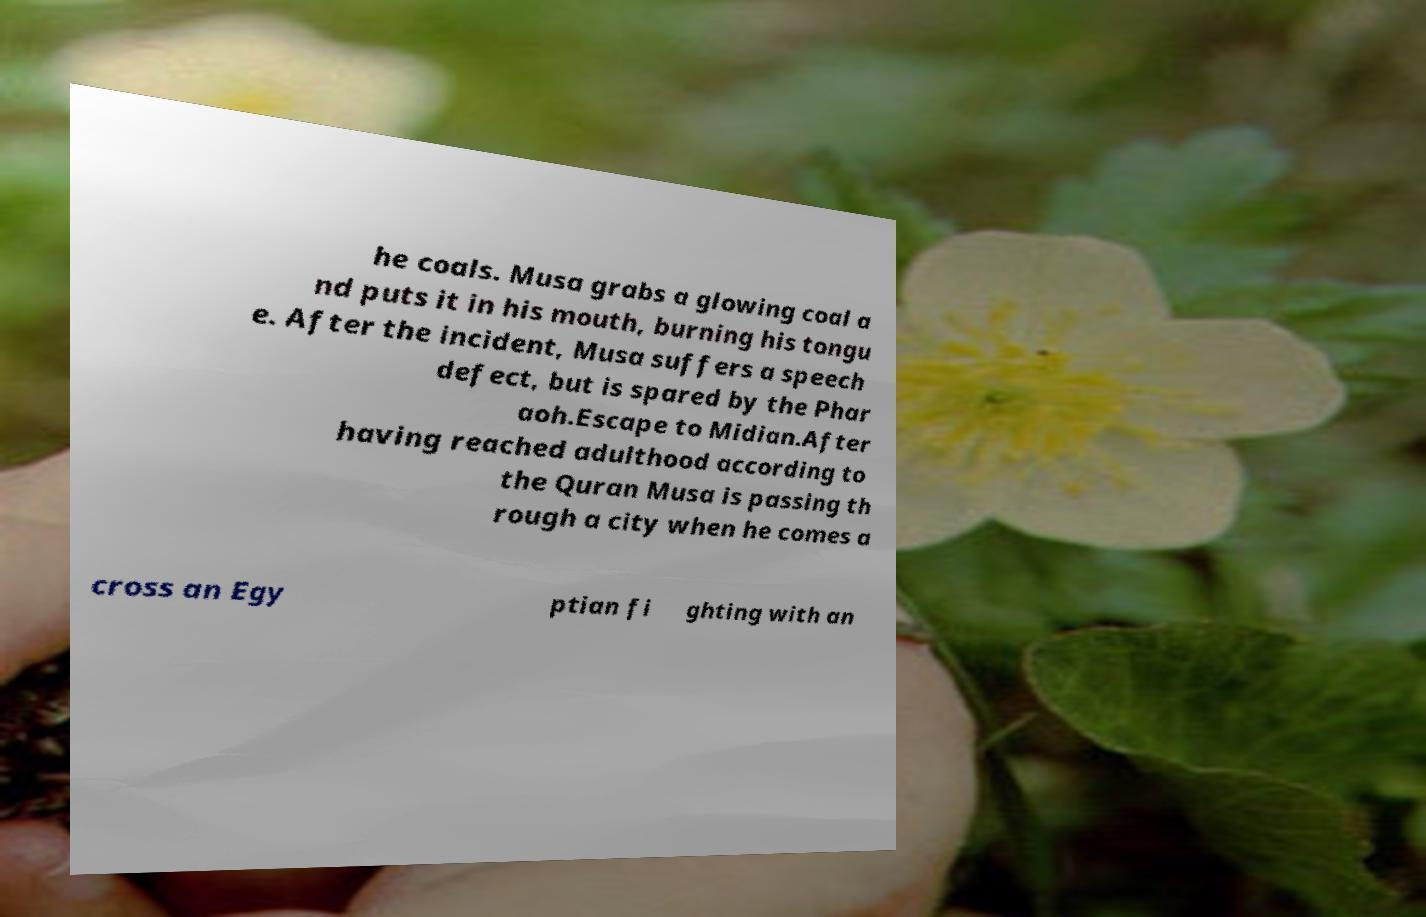I need the written content from this picture converted into text. Can you do that? he coals. Musa grabs a glowing coal a nd puts it in his mouth, burning his tongu e. After the incident, Musa suffers a speech defect, but is spared by the Phar aoh.Escape to Midian.After having reached adulthood according to the Quran Musa is passing th rough a city when he comes a cross an Egy ptian fi ghting with an 